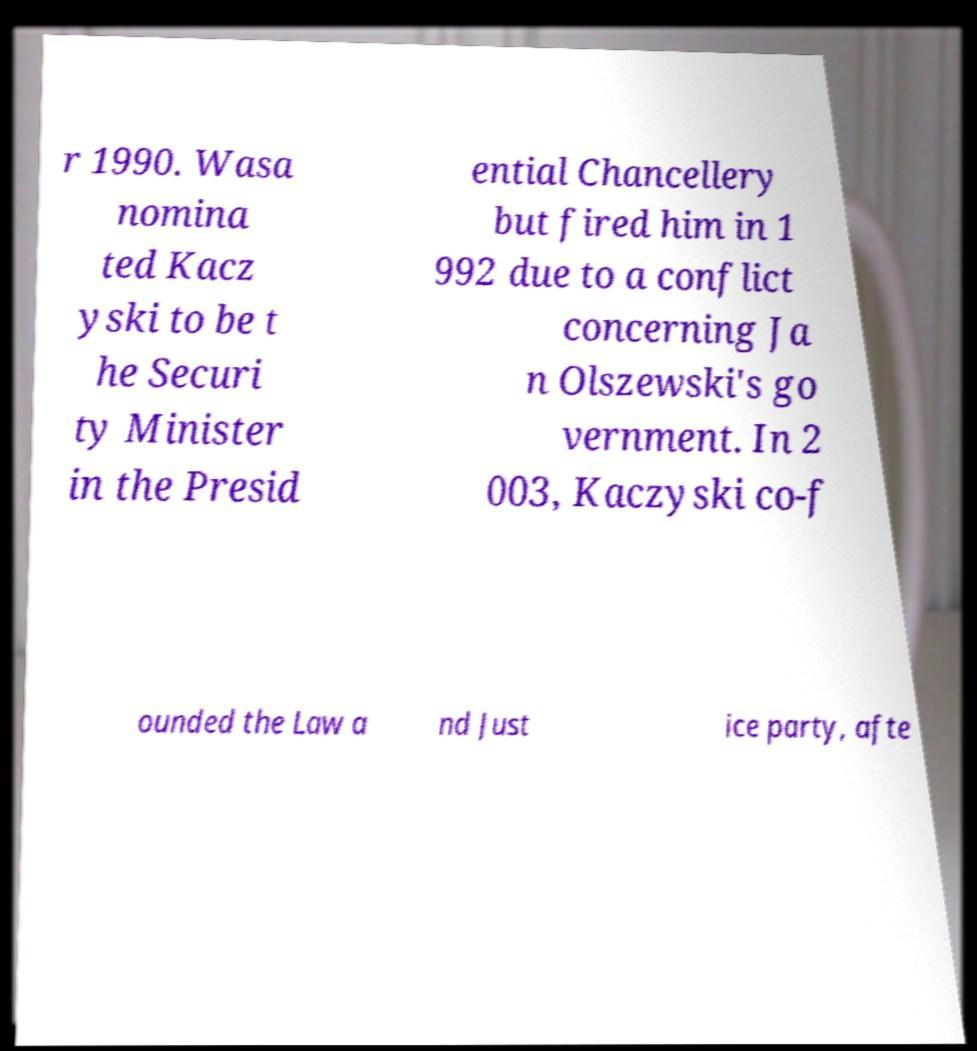Please identify and transcribe the text found in this image. r 1990. Wasa nomina ted Kacz yski to be t he Securi ty Minister in the Presid ential Chancellery but fired him in 1 992 due to a conflict concerning Ja n Olszewski's go vernment. In 2 003, Kaczyski co-f ounded the Law a nd Just ice party, afte 